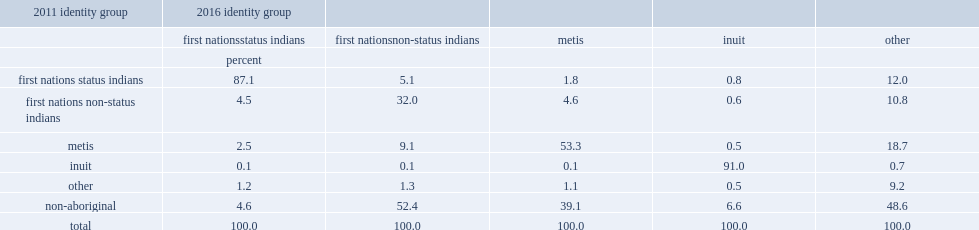What is the percentage of the 2016 first nations non-status indian population in the integrated dataset had reported being non-aboriginal on the previous census? 52.4. There was also a significant inflow from the non-aboriginal population to the 2016 metis population. of those who identified as metis in 2016, what percentage had identified as non-aboriginal in 2011? 39.1. Parse the full table. {'header': ['2011 identity group', '2016 identity group', '', '', '', ''], 'rows': [['', 'first nationsstatus indians', 'first nationsnon-status indians', 'metis', 'inuit', 'other'], ['', 'percent', '', '', '', ''], ['first nations status indians', '87.1', '5.1', '1.8', '0.8', '12.0'], ['first nations non-status indians', '4.5', '32.0', '4.6', '0.6', '10.8'], ['metis', '2.5', '9.1', '53.3', '0.5', '18.7'], ['inuit', '0.1', '0.1', '0.1', '91.0', '0.7'], ['other', '1.2', '1.3', '1.1', '0.5', '9.2'], ['non-aboriginal', '4.6', '52.4', '39.1', '6.6', '48.6'], ['total', '100.0', '100.0', '100.0', '100.0', '100.0']]} 